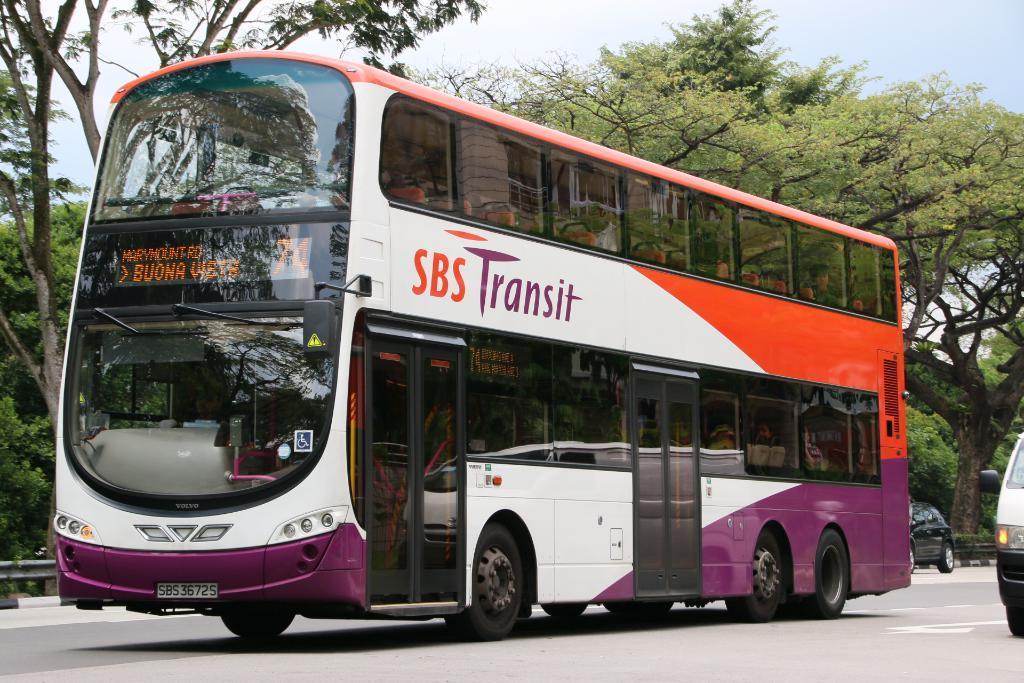Describe this image in one or two sentences. In this image there is a bus present on the road and there are also two cars visible. In the background there are trees. Sky is also visible. 